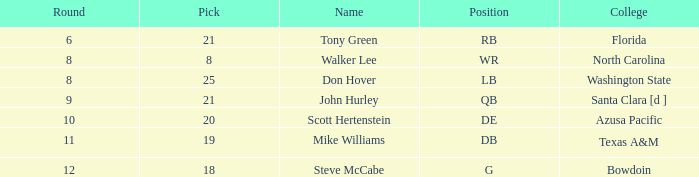How many overalls feature a pick more than 19, with florida as the educational institution? 159.0. 